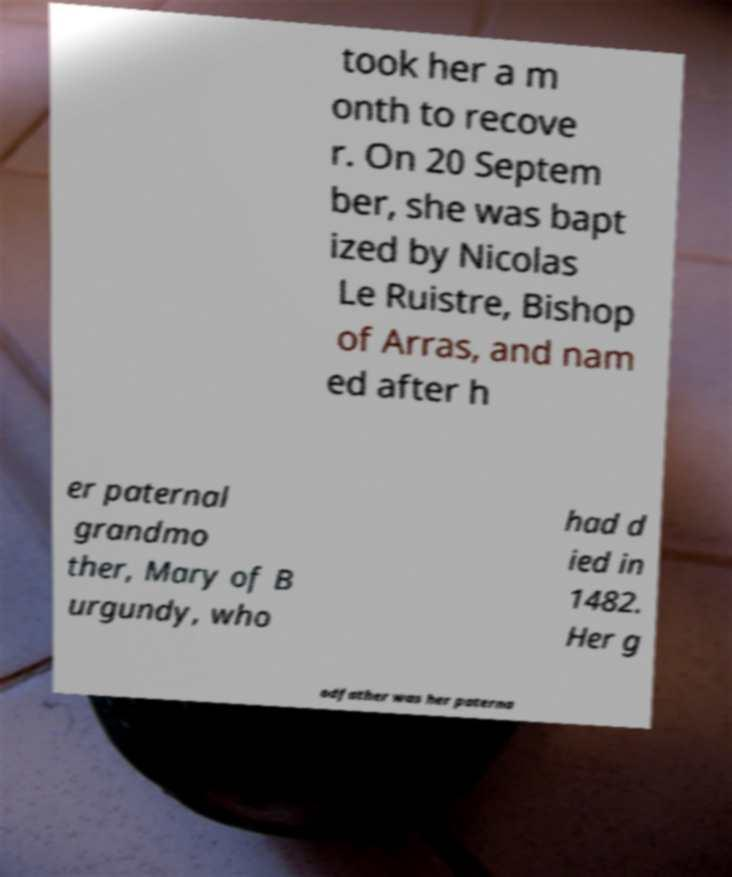Can you accurately transcribe the text from the provided image for me? took her a m onth to recove r. On 20 Septem ber, she was bapt ized by Nicolas Le Ruistre, Bishop of Arras, and nam ed after h er paternal grandmo ther, Mary of B urgundy, who had d ied in 1482. Her g odfather was her paterna 